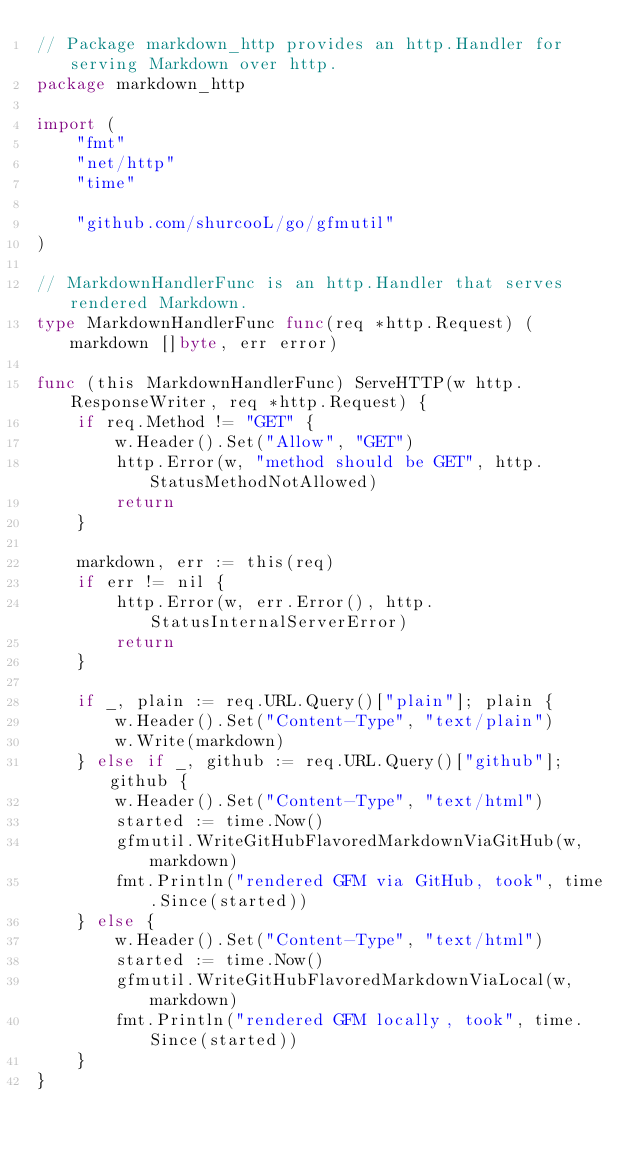Convert code to text. <code><loc_0><loc_0><loc_500><loc_500><_Go_>// Package markdown_http provides an http.Handler for serving Markdown over http.
package markdown_http

import (
	"fmt"
	"net/http"
	"time"

	"github.com/shurcooL/go/gfmutil"
)

// MarkdownHandlerFunc is an http.Handler that serves rendered Markdown.
type MarkdownHandlerFunc func(req *http.Request) (markdown []byte, err error)

func (this MarkdownHandlerFunc) ServeHTTP(w http.ResponseWriter, req *http.Request) {
	if req.Method != "GET" {
		w.Header().Set("Allow", "GET")
		http.Error(w, "method should be GET", http.StatusMethodNotAllowed)
		return
	}

	markdown, err := this(req)
	if err != nil {
		http.Error(w, err.Error(), http.StatusInternalServerError)
		return
	}

	if _, plain := req.URL.Query()["plain"]; plain {
		w.Header().Set("Content-Type", "text/plain")
		w.Write(markdown)
	} else if _, github := req.URL.Query()["github"]; github {
		w.Header().Set("Content-Type", "text/html")
		started := time.Now()
		gfmutil.WriteGitHubFlavoredMarkdownViaGitHub(w, markdown)
		fmt.Println("rendered GFM via GitHub, took", time.Since(started))
	} else {
		w.Header().Set("Content-Type", "text/html")
		started := time.Now()
		gfmutil.WriteGitHubFlavoredMarkdownViaLocal(w, markdown)
		fmt.Println("rendered GFM locally, took", time.Since(started))
	}
}
</code> 